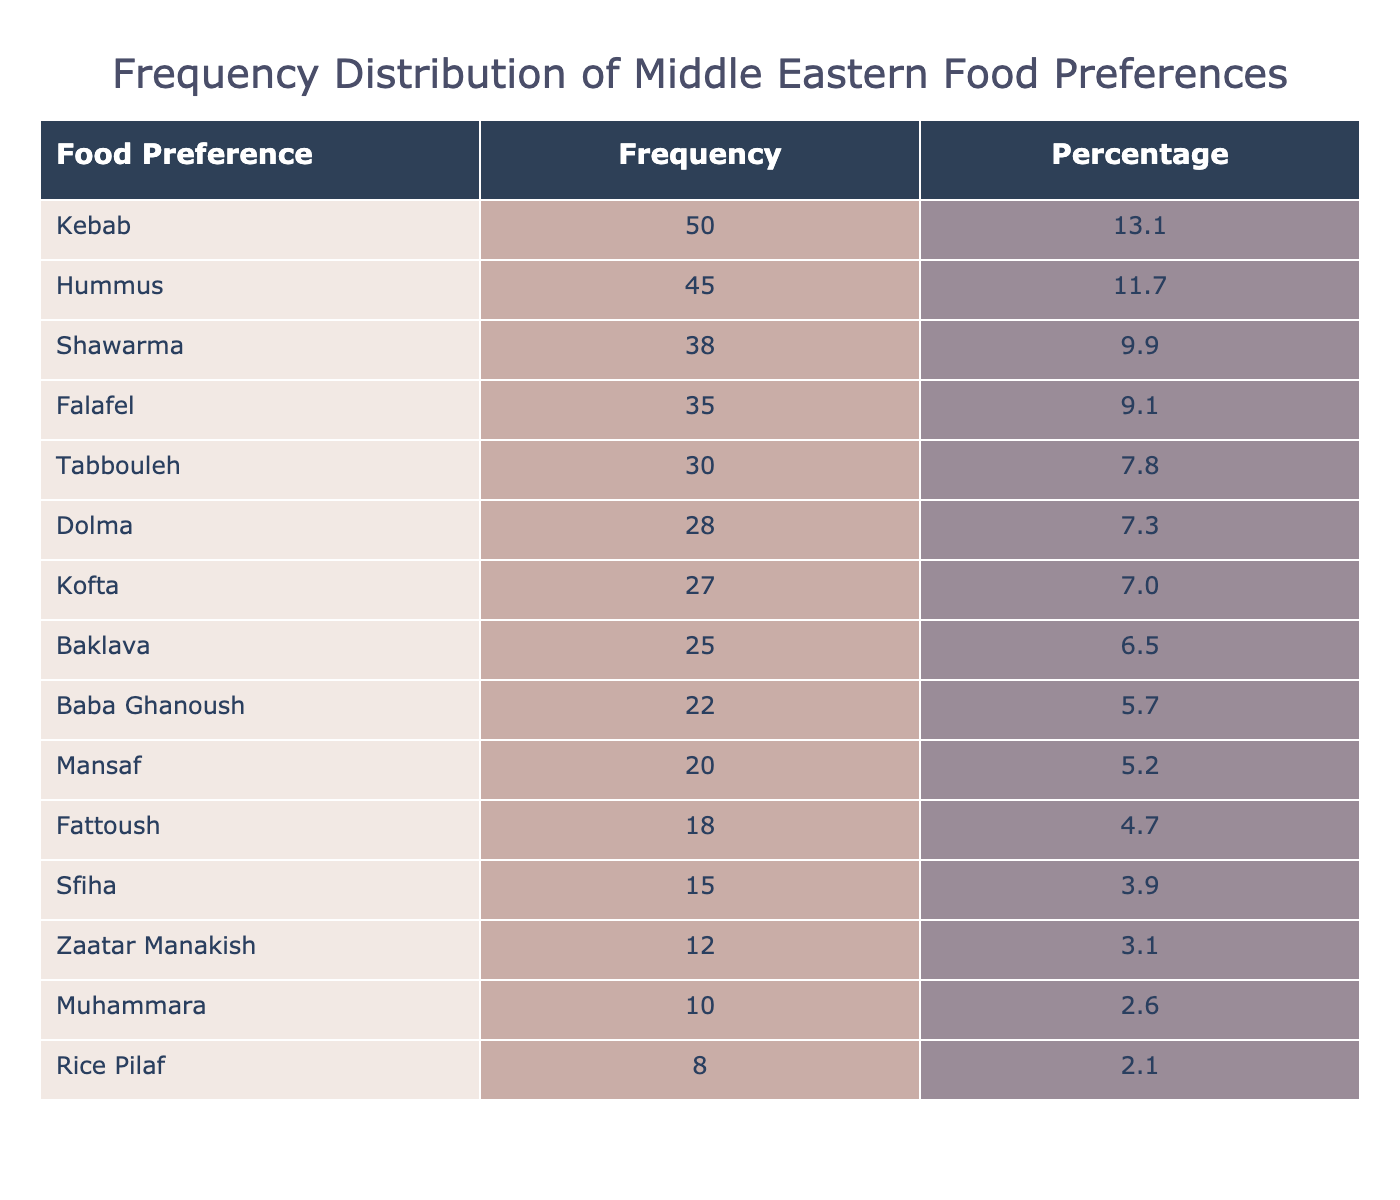What is the most popular food preference among the Middle Eastern international students? The table lists "Kebab" with the highest occurrence of 50, making it the most popular food preference.
Answer: Kebab How many students preferred Baklava? The table shows that "Baklava" has an occurrence of 25, indicating that 25 students preferred it.
Answer: 25 What is the total occurrence of food preferences represented in the table? To find the total, we add all the occurrences: 45 + 38 + 35 + 30 + 50 + 25 + 20 + 28 + 22 + 27 + 18 + 15 + 12 + 10 + 8 =  397.
Answer: 397 Is the occurrence of Hummus greater than that of Tabbouleh? The table shows that Hummus has an occurrence of 45 and Tabbouleh has 30, thus Hummus is greater than Tabbouleh.
Answer: Yes If we combine the occurrences of Kofta and Dolma, what is the total? Kofta has an occurrence of 27 and Dolma has 28, so 27 + 28 = 55 gives the total occurrence.
Answer: 55 Which food preference is the least favored among students? The table indicates that "Rice Pilaf" has the lowest occurrence at 8, identifying it as the least favored option.
Answer: Rice Pilaf What percentage of students prefer Shawarma compared to the total occurrences? Shawarma's occurrence is 38. To find the percentage, divide 38 by the total occurrences (397) and multiply by 100. So, (38 / 397) * 100 ≈ 9.6%.
Answer: 9.6% Are more students likely to prefer Falafel than Baklava? The table shows that 35 students prefer Falafel and 25 prefer Baklava. Since 35 is greater than 25, more students prefer Falafel.
Answer: Yes What is the average occurrence of food preferences listed in the table? The total occurrence is 397, and since there are 15 food preferences listed, we calculate the average by dividing: 397 / 15 ≈ 26.5.
Answer: 26.5 